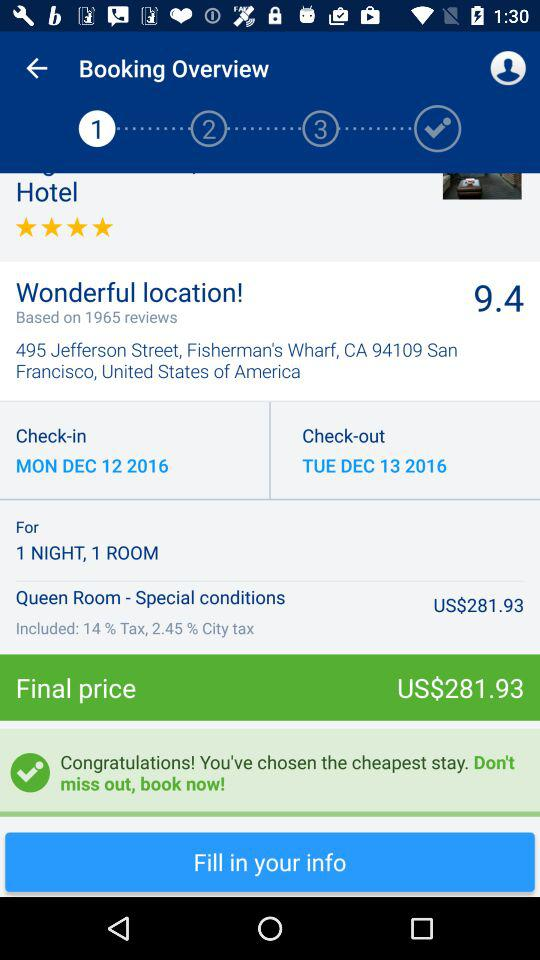What is the check-in date? The check-in date is Monday, December 12, 2016. 